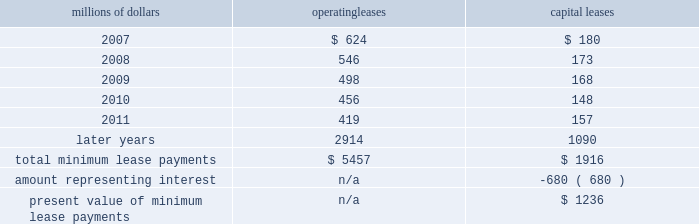Depending upon our senior unsecured debt ratings .
The facilities require the maintenance of a minimum net worth and a debt to net worth coverage ratio .
At december 31 , 2006 , we were in compliance with these covenants .
The facilities do not include any other financial restrictions , credit rating triggers ( other than rating-dependent pricing ) , or any other provision that could require the posting of collateral .
In addition to our revolving credit facilities , we had $ 150 million in uncommitted lines of credit available , including $ 75 million that expires in march 2007 and $ 75 million expiring in may 2007 .
Neither of these lines of credit were used as of december 31 , 2006 .
We must have equivalent credit available under our five-year facilities to draw on these $ 75 million lines .
Dividend restrictions 2013 we are subject to certain restrictions related to the payment of cash dividends to our shareholders due to minimum net worth requirements under the credit facilities referred to above .
The amount of retained earnings available for dividends was $ 7.8 billion and $ 6.2 billion at december 31 , 2006 and 2005 , respectively .
We do not expect that these restrictions will have a material adverse effect on our consolidated financial condition , results of operations , or liquidity .
We declared dividends of $ 323 million in 2006 and $ 316 million in 2005 .
Shelf registration statement 2013 under a current shelf registration statement , we may issue any combination of debt securities , preferred stock , common stock , or warrants for debt securities or preferred stock in one or more offerings .
At december 31 , 2006 , we had $ 500 million remaining for issuance under the current shelf registration statement .
We have no immediate plans to issue any securities ; however , we routinely consider and evaluate opportunities to replace existing debt or access capital through issuances of debt securities under this shelf registration , and , therefore , we may issue debt securities at any time .
Leases we lease certain locomotives , freight cars , and other property .
Future minimum lease payments for operating and capital leases with initial or remaining non-cancelable lease terms in excess of one year as of december 31 , 2006 were as follows : millions of dollars operating leases capital leases .
Rent expense for operating leases with terms exceeding one month was $ 798 million in 2006 , $ 728 million in 2005 , and $ 651 million in 2004 .
When cash rental payments are not made on a straight-line basis , we recognize variable rental expense on a straight-line basis over the lease term .
Contingent rentals and sub-rentals are not significant. .
What percentage of total minimum lease payments are capital leases as of december 31 , 2006? 
Computations: (1916 / (5457 + 1916))
Answer: 0.25987. 